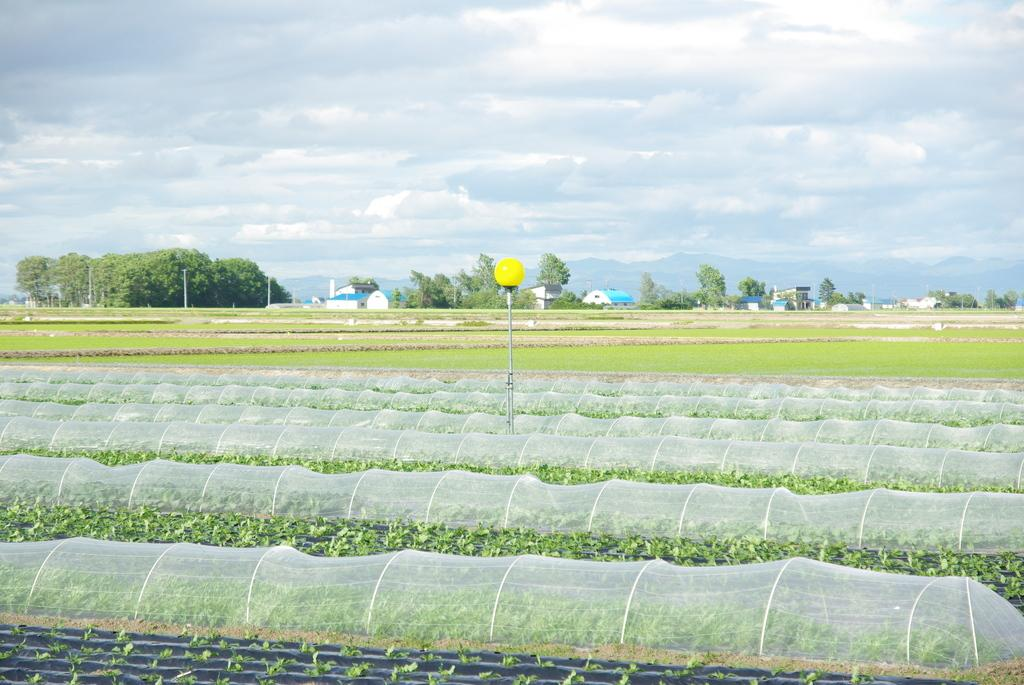What type of landscape is depicted in the image? The image features farm lands. What can be seen in the background of the image? There are trees and houses in the background of the image. What is the weather like in the image? The sky is sunny in the background of the image. How many ducks are sitting on the quilt in the image? There are no ducks or quilts present in the image. What type of sheep can be seen grazing in the farm lands? There are no sheep visible in the image; only farm lands are depicted. 